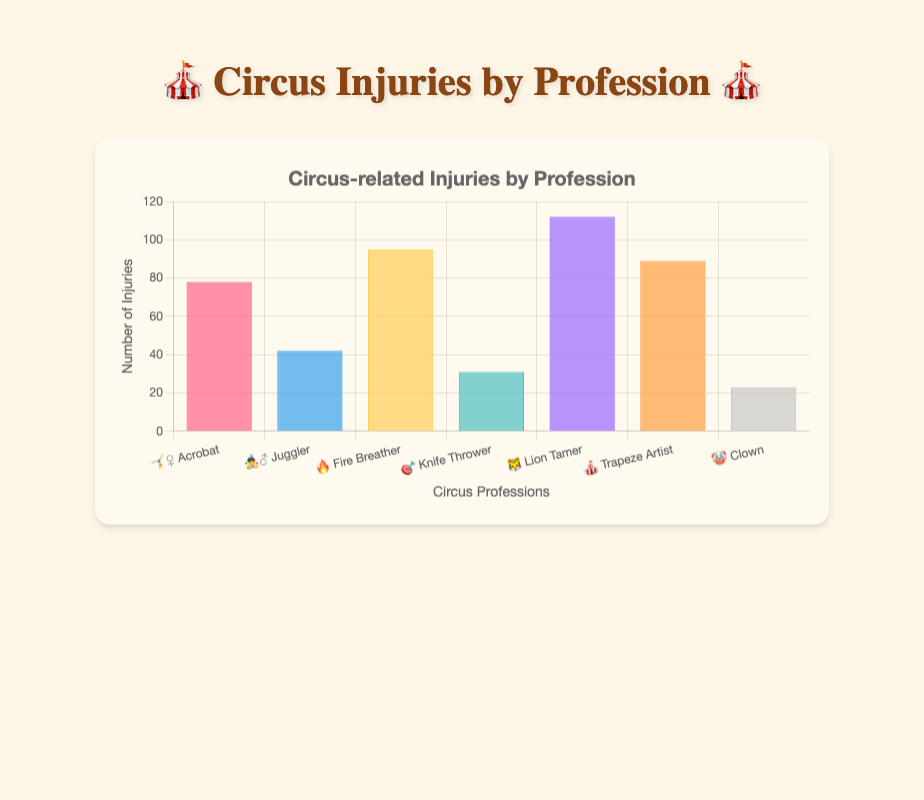Which profession has the most injuries? According to the chart, the profession with the highest number of injuries is the Lion Tamer, represented by the emoji 🐯. The y-axis denotes the number of injuries, and the bar for 🐯 Lion Tamer reaches the highest point at 112 injuries.
Answer: Lion Tamer How many total injuries are represented in the chart? To find the total number of injuries, sum the injuries for each profession: Acrobat (78) + Juggler (42) + Fire Breather (95) + Knife Thrower (31) + Lion Tamer (112) + Trapeze Artist (89) + Clown (23). The total is 78 + 42 + 95 + 31 + 112 + 89 + 23 = 470.
Answer: 470 Which profession has fewer injuries, Fire Breather or Trapeze Artist? Fire Breather has 95 injuries while Trapeze Artist has 89. Comparatively, Fire Breathers have more injuries than Trapeze Artists.
Answer: Trapeze Artist What is the average number of injuries per profession? Sum the total number of injuries (470) and divide by the number of professions (7). The average is 470 / 7 = 67.14.
Answer: 67.14 Is the number of injuries for Clowns greater than that of Knife Throwers? Clowns have 23 injuries, while Knife Throwers have 31 injuries. Clowns have fewer injuries than Knife Throwers.
Answer: No What is the difference in the number of injuries between the profession with the most injuries and the profession with the least injuries? The profession with the most injuries (Lion Tamer) has 112 and the profession with the least injuries (Clown) has 23. The difference is 112 - 23 = 89 injuries.
Answer: 89 List the professions in descending order of injuries. The order from highest to lowest injuries is: Lion Tamer (112), Fire Breather (95), Trapeze Artist (89), Acrobat (78), Juggler (42), Knife Thrower (31), and Clown (23).
Answer: Lion Tamer, Fire Breather, Trapeze Artist, Acrobat, Juggler, Knife Thrower, Clown Which two professions have the closest number of injuries? Acrobat and Trapeze Artist have the closest numbers with 78 and 89 injuries, respectively. The difference between them is 89 - 78 = 11 injuries.
Answer: Acrobat and Trapeze Artist How many more injuries do Lion Tamers have than Jugglers? Lion Tamers have 112 injuries, and Jugglers have 42 injuries. The difference is 112 - 42 = 70 injuries.
Answer: 70 